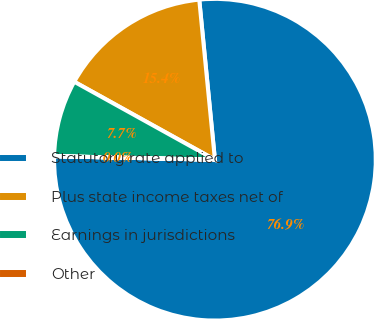Convert chart to OTSL. <chart><loc_0><loc_0><loc_500><loc_500><pie_chart><fcel>Statutory rate applied to<fcel>Plus state income taxes net of<fcel>Earnings in jurisdictions<fcel>Other<nl><fcel>76.89%<fcel>15.39%<fcel>7.7%<fcel>0.01%<nl></chart> 